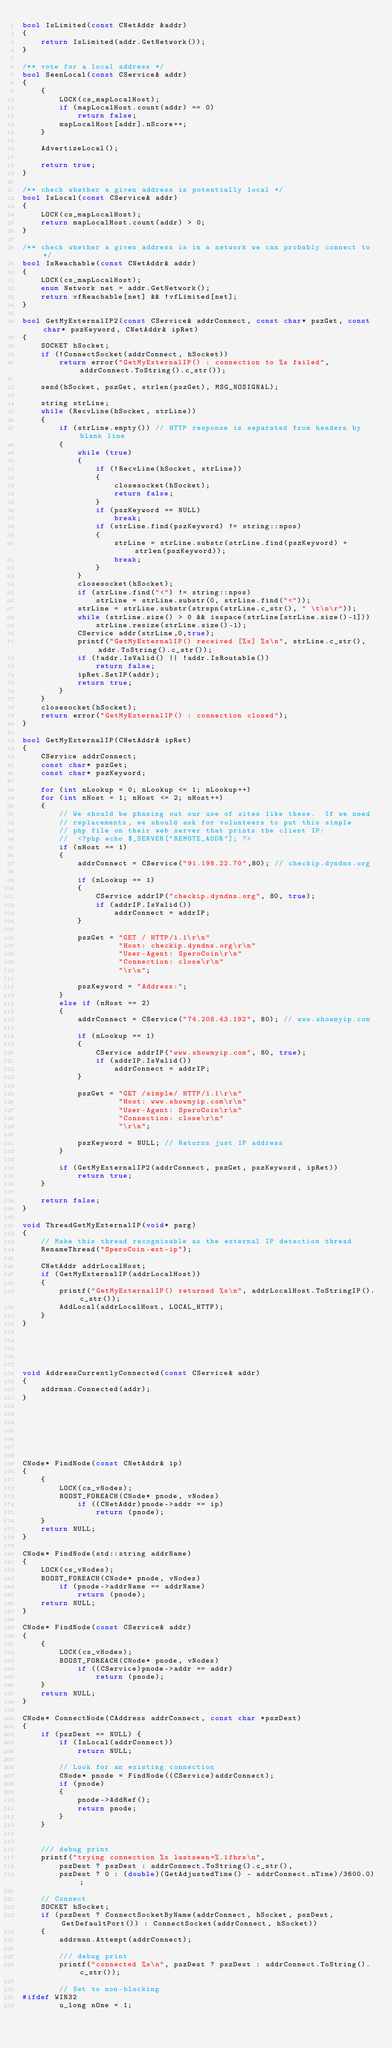Convert code to text. <code><loc_0><loc_0><loc_500><loc_500><_C++_>bool IsLimited(const CNetAddr &addr)
{
    return IsLimited(addr.GetNetwork());
}

/** vote for a local address */
bool SeenLocal(const CService& addr)
{
    {
        LOCK(cs_mapLocalHost);
        if (mapLocalHost.count(addr) == 0)
            return false;
        mapLocalHost[addr].nScore++;
    }

    AdvertizeLocal();

    return true;
}

/** check whether a given address is potentially local */
bool IsLocal(const CService& addr)
{
    LOCK(cs_mapLocalHost);
    return mapLocalHost.count(addr) > 0;
}

/** check whether a given address is in a network we can probably connect to */
bool IsReachable(const CNetAddr& addr)
{
    LOCK(cs_mapLocalHost);
    enum Network net = addr.GetNetwork();
    return vfReachable[net] && !vfLimited[net];
}

bool GetMyExternalIP2(const CService& addrConnect, const char* pszGet, const char* pszKeyword, CNetAddr& ipRet)
{
    SOCKET hSocket;
    if (!ConnectSocket(addrConnect, hSocket))
        return error("GetMyExternalIP() : connection to %s failed", addrConnect.ToString().c_str());

    send(hSocket, pszGet, strlen(pszGet), MSG_NOSIGNAL);

    string strLine;
    while (RecvLine(hSocket, strLine))
    {
        if (strLine.empty()) // HTTP response is separated from headers by blank line
        {
            while (true)
            {
                if (!RecvLine(hSocket, strLine))
                {
                    closesocket(hSocket);
                    return false;
                }
                if (pszKeyword == NULL)
                    break;
                if (strLine.find(pszKeyword) != string::npos)
                {
                    strLine = strLine.substr(strLine.find(pszKeyword) + strlen(pszKeyword));
                    break;
                }
            }
            closesocket(hSocket);
            if (strLine.find("<") != string::npos)
                strLine = strLine.substr(0, strLine.find("<"));
            strLine = strLine.substr(strspn(strLine.c_str(), " \t\n\r"));
            while (strLine.size() > 0 && isspace(strLine[strLine.size()-1]))
                strLine.resize(strLine.size()-1);
            CService addr(strLine,0,true);
            printf("GetMyExternalIP() received [%s] %s\n", strLine.c_str(), addr.ToString().c_str());
            if (!addr.IsValid() || !addr.IsRoutable())
                return false;
            ipRet.SetIP(addr);
            return true;
        }
    }
    closesocket(hSocket);
    return error("GetMyExternalIP() : connection closed");
}

bool GetMyExternalIP(CNetAddr& ipRet)
{
    CService addrConnect;
    const char* pszGet;
    const char* pszKeyword;

    for (int nLookup = 0; nLookup <= 1; nLookup++)
    for (int nHost = 1; nHost <= 2; nHost++)
    {
        // We should be phasing out our use of sites like these.  If we need
        // replacements, we should ask for volunteers to put this simple
        // php file on their web server that prints the client IP:
        //  <?php echo $_SERVER["REMOTE_ADDR"]; ?>
        if (nHost == 1)
        {
            addrConnect = CService("91.198.22.70",80); // checkip.dyndns.org

            if (nLookup == 1)
            {
                CService addrIP("checkip.dyndns.org", 80, true);
                if (addrIP.IsValid())
                    addrConnect = addrIP;
            }

            pszGet = "GET / HTTP/1.1\r\n"
                     "Host: checkip.dyndns.org\r\n"
                     "User-Agent: SperoCoin\r\n"
                     "Connection: close\r\n"
                     "\r\n";

            pszKeyword = "Address:";
        }
        else if (nHost == 2)
        {
            addrConnect = CService("74.208.43.192", 80); // www.showmyip.com

            if (nLookup == 1)
            {
                CService addrIP("www.showmyip.com", 80, true);
                if (addrIP.IsValid())
                    addrConnect = addrIP;
            }

            pszGet = "GET /simple/ HTTP/1.1\r\n"
                     "Host: www.showmyip.com\r\n"
                     "User-Agent: SperoCoin\r\n"
                     "Connection: close\r\n"
                     "\r\n";

            pszKeyword = NULL; // Returns just IP address
        }

        if (GetMyExternalIP2(addrConnect, pszGet, pszKeyword, ipRet))
            return true;
    }

    return false;
}

void ThreadGetMyExternalIP(void* parg)
{
    // Make this thread recognisable as the external IP detection thread
    RenameThread("SperoCoin-ext-ip");

    CNetAddr addrLocalHost;
    if (GetMyExternalIP(addrLocalHost))
    {
        printf("GetMyExternalIP() returned %s\n", addrLocalHost.ToStringIP().c_str());
        AddLocal(addrLocalHost, LOCAL_HTTP);
    }
}





void AddressCurrentlyConnected(const CService& addr)
{
    addrman.Connected(addr);
}







CNode* FindNode(const CNetAddr& ip)
{
    {
        LOCK(cs_vNodes);
        BOOST_FOREACH(CNode* pnode, vNodes)
            if ((CNetAddr)pnode->addr == ip)
                return (pnode);
    }
    return NULL;
}

CNode* FindNode(std::string addrName)
{
    LOCK(cs_vNodes);
    BOOST_FOREACH(CNode* pnode, vNodes)
        if (pnode->addrName == addrName)
            return (pnode);
    return NULL;
}

CNode* FindNode(const CService& addr)
{
    {
        LOCK(cs_vNodes);
        BOOST_FOREACH(CNode* pnode, vNodes)
            if ((CService)pnode->addr == addr)
                return (pnode);
    }
    return NULL;
}

CNode* ConnectNode(CAddress addrConnect, const char *pszDest)
{
    if (pszDest == NULL) {
        if (IsLocal(addrConnect))
            return NULL;

        // Look for an existing connection
        CNode* pnode = FindNode((CService)addrConnect);
        if (pnode)
        {
            pnode->AddRef();
            return pnode;
        }
    }


    /// debug print
    printf("trying connection %s lastseen=%.1fhrs\n",
        pszDest ? pszDest : addrConnect.ToString().c_str(),
        pszDest ? 0 : (double)(GetAdjustedTime() - addrConnect.nTime)/3600.0);

    // Connect
    SOCKET hSocket;
    if (pszDest ? ConnectSocketByName(addrConnect, hSocket, pszDest, GetDefaultPort()) : ConnectSocket(addrConnect, hSocket))
    {
        addrman.Attempt(addrConnect);

        /// debug print
        printf("connected %s\n", pszDest ? pszDest : addrConnect.ToString().c_str());

        // Set to non-blocking
#ifdef WIN32
        u_long nOne = 1;</code> 